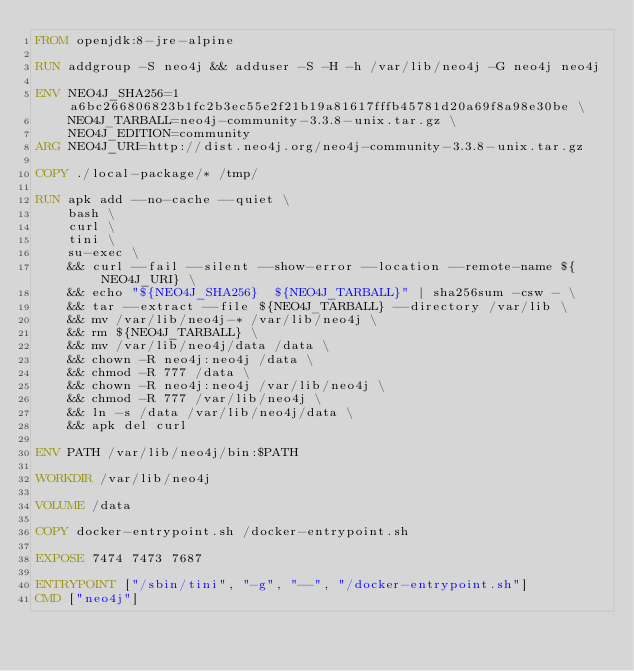<code> <loc_0><loc_0><loc_500><loc_500><_Dockerfile_>FROM openjdk:8-jre-alpine

RUN addgroup -S neo4j && adduser -S -H -h /var/lib/neo4j -G neo4j neo4j

ENV NEO4J_SHA256=1a6bc266806823b1fc2b3ec55e2f21b19a81617fffb45781d20a69f8a98e30be \
    NEO4J_TARBALL=neo4j-community-3.3.8-unix.tar.gz \
    NEO4J_EDITION=community
ARG NEO4J_URI=http://dist.neo4j.org/neo4j-community-3.3.8-unix.tar.gz

COPY ./local-package/* /tmp/

RUN apk add --no-cache --quiet \
    bash \
    curl \
    tini \
    su-exec \
    && curl --fail --silent --show-error --location --remote-name ${NEO4J_URI} \
    && echo "${NEO4J_SHA256}  ${NEO4J_TARBALL}" | sha256sum -csw - \
    && tar --extract --file ${NEO4J_TARBALL} --directory /var/lib \
    && mv /var/lib/neo4j-* /var/lib/neo4j \
    && rm ${NEO4J_TARBALL} \
    && mv /var/lib/neo4j/data /data \
    && chown -R neo4j:neo4j /data \
    && chmod -R 777 /data \
    && chown -R neo4j:neo4j /var/lib/neo4j \
    && chmod -R 777 /var/lib/neo4j \
    && ln -s /data /var/lib/neo4j/data \
    && apk del curl

ENV PATH /var/lib/neo4j/bin:$PATH

WORKDIR /var/lib/neo4j

VOLUME /data

COPY docker-entrypoint.sh /docker-entrypoint.sh

EXPOSE 7474 7473 7687

ENTRYPOINT ["/sbin/tini", "-g", "--", "/docker-entrypoint.sh"]
CMD ["neo4j"]
</code> 